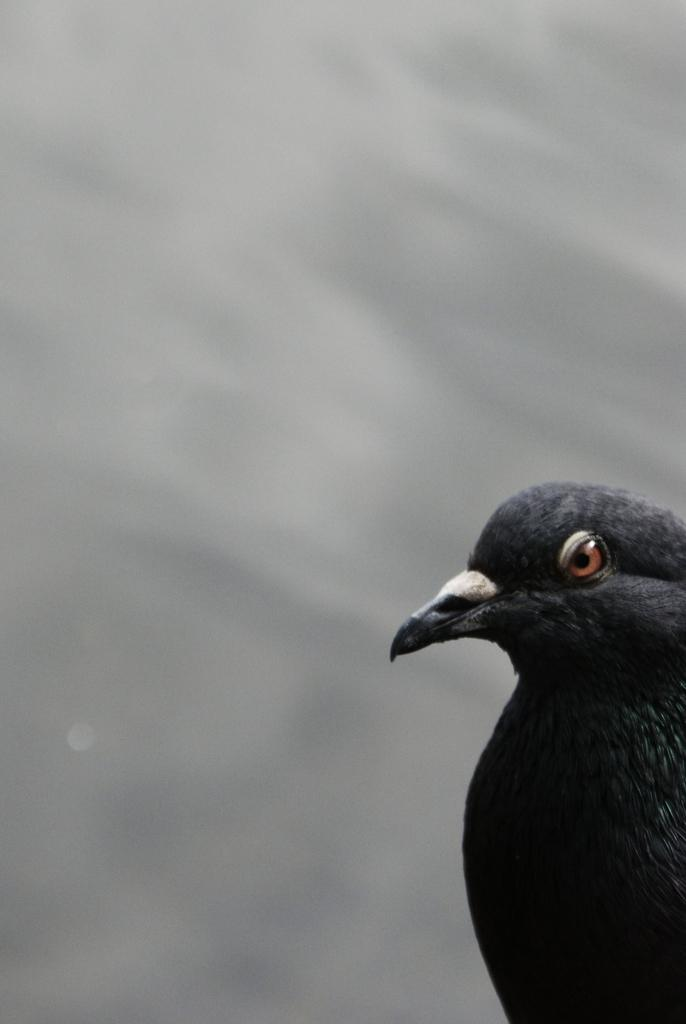What type of bird can be seen in the image? There is a black color bird in the image. Where is the bird located in the image? The bird is located in the right bottom corner of the image. Can you describe the background of the image? The background of the image is not clear enough to describe further details. What type of chalk is the bird using to draw on the lamp in the image? There is no chalk or lamp present in the image; it only features a black color bird in the right bottom corner. 